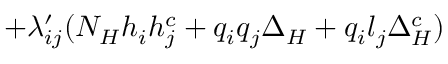<formula> <loc_0><loc_0><loc_500><loc_500>+ { \lambda _ { i j } ^ { \prime } } ( { N _ { H } } { h _ { i } } { h _ { j } ^ { c } } + { q _ { i } } { q _ { j } } { \Delta _ { H } } + { q _ { i } } { l _ { j } } { \Delta _ { H } ^ { c } } )</formula> 